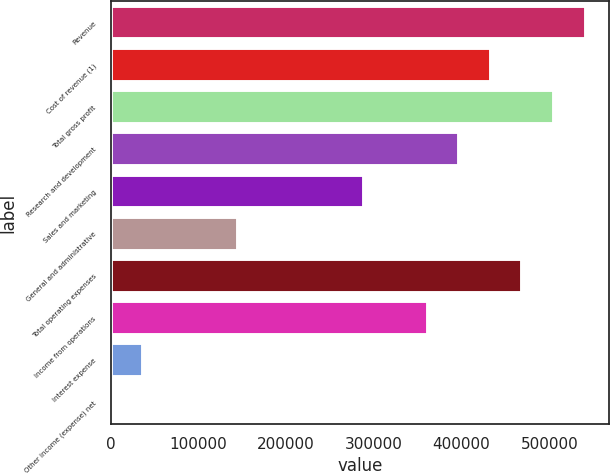Convert chart to OTSL. <chart><loc_0><loc_0><loc_500><loc_500><bar_chart><fcel>Revenue<fcel>Cost of revenue (1)<fcel>Total gross profit<fcel>Research and development<fcel>Sales and marketing<fcel>General and administrative<fcel>Total operating expenses<fcel>Income from operations<fcel>Interest expense<fcel>Other income (expense) net<nl><fcel>541459<fcel>433318<fcel>505412<fcel>397271<fcel>289130<fcel>144942<fcel>469365<fcel>361224<fcel>36801<fcel>754<nl></chart> 